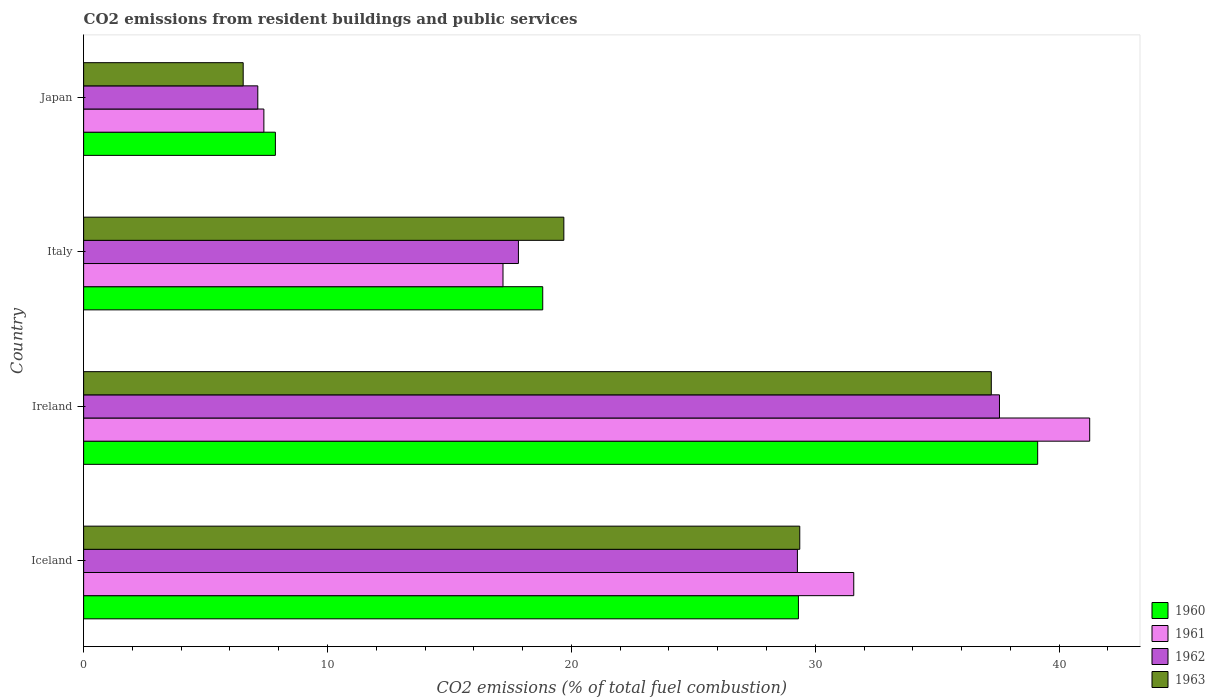Are the number of bars per tick equal to the number of legend labels?
Give a very brief answer. Yes. How many bars are there on the 1st tick from the top?
Offer a very short reply. 4. How many bars are there on the 3rd tick from the bottom?
Your response must be concise. 4. What is the total CO2 emitted in 1962 in Ireland?
Offer a very short reply. 37.55. Across all countries, what is the maximum total CO2 emitted in 1961?
Keep it short and to the point. 41.25. Across all countries, what is the minimum total CO2 emitted in 1963?
Give a very brief answer. 6.54. In which country was the total CO2 emitted in 1961 maximum?
Your answer should be very brief. Ireland. What is the total total CO2 emitted in 1962 in the graph?
Make the answer very short. 91.79. What is the difference between the total CO2 emitted in 1962 in Iceland and that in Ireland?
Your answer should be very brief. -8.29. What is the difference between the total CO2 emitted in 1962 in Japan and the total CO2 emitted in 1963 in Iceland?
Your answer should be compact. -22.22. What is the average total CO2 emitted in 1962 per country?
Your answer should be very brief. 22.95. What is the difference between the total CO2 emitted in 1961 and total CO2 emitted in 1962 in Iceland?
Provide a succinct answer. 2.31. What is the ratio of the total CO2 emitted in 1961 in Italy to that in Japan?
Provide a short and direct response. 2.33. What is the difference between the highest and the second highest total CO2 emitted in 1962?
Provide a succinct answer. 8.29. What is the difference between the highest and the lowest total CO2 emitted in 1962?
Ensure brevity in your answer.  30.41. In how many countries, is the total CO2 emitted in 1960 greater than the average total CO2 emitted in 1960 taken over all countries?
Give a very brief answer. 2. Is it the case that in every country, the sum of the total CO2 emitted in 1963 and total CO2 emitted in 1960 is greater than the sum of total CO2 emitted in 1962 and total CO2 emitted in 1961?
Your response must be concise. No. What does the 3rd bar from the bottom in Japan represents?
Make the answer very short. 1962. Is it the case that in every country, the sum of the total CO2 emitted in 1962 and total CO2 emitted in 1960 is greater than the total CO2 emitted in 1961?
Keep it short and to the point. Yes. How many bars are there?
Keep it short and to the point. 16. What is the difference between two consecutive major ticks on the X-axis?
Ensure brevity in your answer.  10. Are the values on the major ticks of X-axis written in scientific E-notation?
Your answer should be compact. No. Does the graph contain any zero values?
Keep it short and to the point. No. Does the graph contain grids?
Your answer should be compact. No. Where does the legend appear in the graph?
Provide a succinct answer. Bottom right. How many legend labels are there?
Your response must be concise. 4. How are the legend labels stacked?
Make the answer very short. Vertical. What is the title of the graph?
Ensure brevity in your answer.  CO2 emissions from resident buildings and public services. Does "1996" appear as one of the legend labels in the graph?
Provide a short and direct response. No. What is the label or title of the X-axis?
Provide a short and direct response. CO2 emissions (% of total fuel combustion). What is the label or title of the Y-axis?
Your answer should be very brief. Country. What is the CO2 emissions (% of total fuel combustion) of 1960 in Iceland?
Give a very brief answer. 29.31. What is the CO2 emissions (% of total fuel combustion) of 1961 in Iceland?
Keep it short and to the point. 31.58. What is the CO2 emissions (% of total fuel combustion) in 1962 in Iceland?
Make the answer very short. 29.27. What is the CO2 emissions (% of total fuel combustion) in 1963 in Iceland?
Keep it short and to the point. 29.37. What is the CO2 emissions (% of total fuel combustion) in 1960 in Ireland?
Offer a very short reply. 39.12. What is the CO2 emissions (% of total fuel combustion) of 1961 in Ireland?
Offer a terse response. 41.25. What is the CO2 emissions (% of total fuel combustion) of 1962 in Ireland?
Offer a very short reply. 37.55. What is the CO2 emissions (% of total fuel combustion) of 1963 in Ireland?
Offer a very short reply. 37.22. What is the CO2 emissions (% of total fuel combustion) of 1960 in Italy?
Make the answer very short. 18.83. What is the CO2 emissions (% of total fuel combustion) in 1961 in Italy?
Provide a succinct answer. 17.2. What is the CO2 emissions (% of total fuel combustion) in 1962 in Italy?
Your response must be concise. 17.83. What is the CO2 emissions (% of total fuel combustion) of 1963 in Italy?
Offer a terse response. 19.69. What is the CO2 emissions (% of total fuel combustion) of 1960 in Japan?
Keep it short and to the point. 7.86. What is the CO2 emissions (% of total fuel combustion) in 1961 in Japan?
Provide a succinct answer. 7.39. What is the CO2 emissions (% of total fuel combustion) in 1962 in Japan?
Offer a very short reply. 7.14. What is the CO2 emissions (% of total fuel combustion) of 1963 in Japan?
Offer a very short reply. 6.54. Across all countries, what is the maximum CO2 emissions (% of total fuel combustion) of 1960?
Your answer should be very brief. 39.12. Across all countries, what is the maximum CO2 emissions (% of total fuel combustion) of 1961?
Your answer should be compact. 41.25. Across all countries, what is the maximum CO2 emissions (% of total fuel combustion) in 1962?
Offer a terse response. 37.55. Across all countries, what is the maximum CO2 emissions (% of total fuel combustion) in 1963?
Offer a very short reply. 37.22. Across all countries, what is the minimum CO2 emissions (% of total fuel combustion) of 1960?
Keep it short and to the point. 7.86. Across all countries, what is the minimum CO2 emissions (% of total fuel combustion) of 1961?
Ensure brevity in your answer.  7.39. Across all countries, what is the minimum CO2 emissions (% of total fuel combustion) in 1962?
Your answer should be very brief. 7.14. Across all countries, what is the minimum CO2 emissions (% of total fuel combustion) of 1963?
Make the answer very short. 6.54. What is the total CO2 emissions (% of total fuel combustion) of 1960 in the graph?
Make the answer very short. 95.12. What is the total CO2 emissions (% of total fuel combustion) of 1961 in the graph?
Your answer should be compact. 97.42. What is the total CO2 emissions (% of total fuel combustion) in 1962 in the graph?
Ensure brevity in your answer.  91.79. What is the total CO2 emissions (% of total fuel combustion) in 1963 in the graph?
Provide a short and direct response. 92.82. What is the difference between the CO2 emissions (% of total fuel combustion) in 1960 in Iceland and that in Ireland?
Your response must be concise. -9.81. What is the difference between the CO2 emissions (% of total fuel combustion) in 1961 in Iceland and that in Ireland?
Your answer should be compact. -9.67. What is the difference between the CO2 emissions (% of total fuel combustion) in 1962 in Iceland and that in Ireland?
Give a very brief answer. -8.29. What is the difference between the CO2 emissions (% of total fuel combustion) in 1963 in Iceland and that in Ireland?
Ensure brevity in your answer.  -7.85. What is the difference between the CO2 emissions (% of total fuel combustion) of 1960 in Iceland and that in Italy?
Make the answer very short. 10.48. What is the difference between the CO2 emissions (% of total fuel combustion) in 1961 in Iceland and that in Italy?
Make the answer very short. 14.38. What is the difference between the CO2 emissions (% of total fuel combustion) in 1962 in Iceland and that in Italy?
Offer a very short reply. 11.44. What is the difference between the CO2 emissions (% of total fuel combustion) in 1963 in Iceland and that in Italy?
Make the answer very short. 9.67. What is the difference between the CO2 emissions (% of total fuel combustion) of 1960 in Iceland and that in Japan?
Ensure brevity in your answer.  21.45. What is the difference between the CO2 emissions (% of total fuel combustion) of 1961 in Iceland and that in Japan?
Offer a very short reply. 24.19. What is the difference between the CO2 emissions (% of total fuel combustion) in 1962 in Iceland and that in Japan?
Give a very brief answer. 22.13. What is the difference between the CO2 emissions (% of total fuel combustion) of 1963 in Iceland and that in Japan?
Keep it short and to the point. 22.82. What is the difference between the CO2 emissions (% of total fuel combustion) in 1960 in Ireland and that in Italy?
Offer a terse response. 20.29. What is the difference between the CO2 emissions (% of total fuel combustion) in 1961 in Ireland and that in Italy?
Your answer should be very brief. 24.06. What is the difference between the CO2 emissions (% of total fuel combustion) of 1962 in Ireland and that in Italy?
Ensure brevity in your answer.  19.73. What is the difference between the CO2 emissions (% of total fuel combustion) in 1963 in Ireland and that in Italy?
Offer a terse response. 17.53. What is the difference between the CO2 emissions (% of total fuel combustion) in 1960 in Ireland and that in Japan?
Your answer should be compact. 31.26. What is the difference between the CO2 emissions (% of total fuel combustion) in 1961 in Ireland and that in Japan?
Provide a short and direct response. 33.86. What is the difference between the CO2 emissions (% of total fuel combustion) of 1962 in Ireland and that in Japan?
Provide a short and direct response. 30.41. What is the difference between the CO2 emissions (% of total fuel combustion) of 1963 in Ireland and that in Japan?
Ensure brevity in your answer.  30.68. What is the difference between the CO2 emissions (% of total fuel combustion) of 1960 in Italy and that in Japan?
Give a very brief answer. 10.96. What is the difference between the CO2 emissions (% of total fuel combustion) of 1961 in Italy and that in Japan?
Offer a very short reply. 9.81. What is the difference between the CO2 emissions (% of total fuel combustion) in 1962 in Italy and that in Japan?
Ensure brevity in your answer.  10.69. What is the difference between the CO2 emissions (% of total fuel combustion) in 1963 in Italy and that in Japan?
Offer a very short reply. 13.15. What is the difference between the CO2 emissions (% of total fuel combustion) in 1960 in Iceland and the CO2 emissions (% of total fuel combustion) in 1961 in Ireland?
Your answer should be compact. -11.94. What is the difference between the CO2 emissions (% of total fuel combustion) in 1960 in Iceland and the CO2 emissions (% of total fuel combustion) in 1962 in Ireland?
Your answer should be compact. -8.24. What is the difference between the CO2 emissions (% of total fuel combustion) of 1960 in Iceland and the CO2 emissions (% of total fuel combustion) of 1963 in Ireland?
Your answer should be compact. -7.91. What is the difference between the CO2 emissions (% of total fuel combustion) in 1961 in Iceland and the CO2 emissions (% of total fuel combustion) in 1962 in Ireland?
Your answer should be compact. -5.98. What is the difference between the CO2 emissions (% of total fuel combustion) of 1961 in Iceland and the CO2 emissions (% of total fuel combustion) of 1963 in Ireland?
Offer a terse response. -5.64. What is the difference between the CO2 emissions (% of total fuel combustion) of 1962 in Iceland and the CO2 emissions (% of total fuel combustion) of 1963 in Ireland?
Keep it short and to the point. -7.95. What is the difference between the CO2 emissions (% of total fuel combustion) in 1960 in Iceland and the CO2 emissions (% of total fuel combustion) in 1961 in Italy?
Your response must be concise. 12.11. What is the difference between the CO2 emissions (% of total fuel combustion) in 1960 in Iceland and the CO2 emissions (% of total fuel combustion) in 1962 in Italy?
Keep it short and to the point. 11.48. What is the difference between the CO2 emissions (% of total fuel combustion) in 1960 in Iceland and the CO2 emissions (% of total fuel combustion) in 1963 in Italy?
Provide a short and direct response. 9.62. What is the difference between the CO2 emissions (% of total fuel combustion) of 1961 in Iceland and the CO2 emissions (% of total fuel combustion) of 1962 in Italy?
Keep it short and to the point. 13.75. What is the difference between the CO2 emissions (% of total fuel combustion) of 1961 in Iceland and the CO2 emissions (% of total fuel combustion) of 1963 in Italy?
Provide a succinct answer. 11.89. What is the difference between the CO2 emissions (% of total fuel combustion) of 1962 in Iceland and the CO2 emissions (% of total fuel combustion) of 1963 in Italy?
Offer a very short reply. 9.58. What is the difference between the CO2 emissions (% of total fuel combustion) of 1960 in Iceland and the CO2 emissions (% of total fuel combustion) of 1961 in Japan?
Keep it short and to the point. 21.92. What is the difference between the CO2 emissions (% of total fuel combustion) in 1960 in Iceland and the CO2 emissions (% of total fuel combustion) in 1962 in Japan?
Keep it short and to the point. 22.17. What is the difference between the CO2 emissions (% of total fuel combustion) of 1960 in Iceland and the CO2 emissions (% of total fuel combustion) of 1963 in Japan?
Keep it short and to the point. 22.77. What is the difference between the CO2 emissions (% of total fuel combustion) in 1961 in Iceland and the CO2 emissions (% of total fuel combustion) in 1962 in Japan?
Offer a very short reply. 24.44. What is the difference between the CO2 emissions (% of total fuel combustion) of 1961 in Iceland and the CO2 emissions (% of total fuel combustion) of 1963 in Japan?
Keep it short and to the point. 25.04. What is the difference between the CO2 emissions (% of total fuel combustion) in 1962 in Iceland and the CO2 emissions (% of total fuel combustion) in 1963 in Japan?
Make the answer very short. 22.73. What is the difference between the CO2 emissions (% of total fuel combustion) in 1960 in Ireland and the CO2 emissions (% of total fuel combustion) in 1961 in Italy?
Provide a short and direct response. 21.92. What is the difference between the CO2 emissions (% of total fuel combustion) in 1960 in Ireland and the CO2 emissions (% of total fuel combustion) in 1962 in Italy?
Provide a short and direct response. 21.29. What is the difference between the CO2 emissions (% of total fuel combustion) of 1960 in Ireland and the CO2 emissions (% of total fuel combustion) of 1963 in Italy?
Keep it short and to the point. 19.43. What is the difference between the CO2 emissions (% of total fuel combustion) of 1961 in Ireland and the CO2 emissions (% of total fuel combustion) of 1962 in Italy?
Provide a short and direct response. 23.42. What is the difference between the CO2 emissions (% of total fuel combustion) of 1961 in Ireland and the CO2 emissions (% of total fuel combustion) of 1963 in Italy?
Offer a terse response. 21.56. What is the difference between the CO2 emissions (% of total fuel combustion) in 1962 in Ireland and the CO2 emissions (% of total fuel combustion) in 1963 in Italy?
Offer a terse response. 17.86. What is the difference between the CO2 emissions (% of total fuel combustion) in 1960 in Ireland and the CO2 emissions (% of total fuel combustion) in 1961 in Japan?
Provide a succinct answer. 31.73. What is the difference between the CO2 emissions (% of total fuel combustion) in 1960 in Ireland and the CO2 emissions (% of total fuel combustion) in 1962 in Japan?
Give a very brief answer. 31.98. What is the difference between the CO2 emissions (% of total fuel combustion) of 1960 in Ireland and the CO2 emissions (% of total fuel combustion) of 1963 in Japan?
Your response must be concise. 32.58. What is the difference between the CO2 emissions (% of total fuel combustion) of 1961 in Ireland and the CO2 emissions (% of total fuel combustion) of 1962 in Japan?
Offer a very short reply. 34.11. What is the difference between the CO2 emissions (% of total fuel combustion) in 1961 in Ireland and the CO2 emissions (% of total fuel combustion) in 1963 in Japan?
Offer a terse response. 34.71. What is the difference between the CO2 emissions (% of total fuel combustion) in 1962 in Ireland and the CO2 emissions (% of total fuel combustion) in 1963 in Japan?
Ensure brevity in your answer.  31.01. What is the difference between the CO2 emissions (% of total fuel combustion) of 1960 in Italy and the CO2 emissions (% of total fuel combustion) of 1961 in Japan?
Ensure brevity in your answer.  11.43. What is the difference between the CO2 emissions (% of total fuel combustion) in 1960 in Italy and the CO2 emissions (% of total fuel combustion) in 1962 in Japan?
Your answer should be very brief. 11.68. What is the difference between the CO2 emissions (% of total fuel combustion) of 1960 in Italy and the CO2 emissions (% of total fuel combustion) of 1963 in Japan?
Offer a terse response. 12.28. What is the difference between the CO2 emissions (% of total fuel combustion) in 1961 in Italy and the CO2 emissions (% of total fuel combustion) in 1962 in Japan?
Your response must be concise. 10.05. What is the difference between the CO2 emissions (% of total fuel combustion) in 1961 in Italy and the CO2 emissions (% of total fuel combustion) in 1963 in Japan?
Keep it short and to the point. 10.65. What is the difference between the CO2 emissions (% of total fuel combustion) in 1962 in Italy and the CO2 emissions (% of total fuel combustion) in 1963 in Japan?
Provide a succinct answer. 11.29. What is the average CO2 emissions (% of total fuel combustion) in 1960 per country?
Ensure brevity in your answer.  23.78. What is the average CO2 emissions (% of total fuel combustion) of 1961 per country?
Your response must be concise. 24.36. What is the average CO2 emissions (% of total fuel combustion) of 1962 per country?
Keep it short and to the point. 22.95. What is the average CO2 emissions (% of total fuel combustion) in 1963 per country?
Offer a terse response. 23.2. What is the difference between the CO2 emissions (% of total fuel combustion) of 1960 and CO2 emissions (% of total fuel combustion) of 1961 in Iceland?
Provide a succinct answer. -2.27. What is the difference between the CO2 emissions (% of total fuel combustion) of 1960 and CO2 emissions (% of total fuel combustion) of 1962 in Iceland?
Keep it short and to the point. 0.04. What is the difference between the CO2 emissions (% of total fuel combustion) in 1960 and CO2 emissions (% of total fuel combustion) in 1963 in Iceland?
Make the answer very short. -0.05. What is the difference between the CO2 emissions (% of total fuel combustion) of 1961 and CO2 emissions (% of total fuel combustion) of 1962 in Iceland?
Provide a succinct answer. 2.31. What is the difference between the CO2 emissions (% of total fuel combustion) of 1961 and CO2 emissions (% of total fuel combustion) of 1963 in Iceland?
Give a very brief answer. 2.21. What is the difference between the CO2 emissions (% of total fuel combustion) in 1962 and CO2 emissions (% of total fuel combustion) in 1963 in Iceland?
Provide a succinct answer. -0.1. What is the difference between the CO2 emissions (% of total fuel combustion) in 1960 and CO2 emissions (% of total fuel combustion) in 1961 in Ireland?
Keep it short and to the point. -2.13. What is the difference between the CO2 emissions (% of total fuel combustion) in 1960 and CO2 emissions (% of total fuel combustion) in 1962 in Ireland?
Your answer should be compact. 1.57. What is the difference between the CO2 emissions (% of total fuel combustion) of 1960 and CO2 emissions (% of total fuel combustion) of 1963 in Ireland?
Ensure brevity in your answer.  1.9. What is the difference between the CO2 emissions (% of total fuel combustion) in 1961 and CO2 emissions (% of total fuel combustion) in 1962 in Ireland?
Offer a very short reply. 3.7. What is the difference between the CO2 emissions (% of total fuel combustion) in 1961 and CO2 emissions (% of total fuel combustion) in 1963 in Ireland?
Offer a very short reply. 4.03. What is the difference between the CO2 emissions (% of total fuel combustion) in 1962 and CO2 emissions (% of total fuel combustion) in 1963 in Ireland?
Offer a terse response. 0.34. What is the difference between the CO2 emissions (% of total fuel combustion) in 1960 and CO2 emissions (% of total fuel combustion) in 1961 in Italy?
Your answer should be very brief. 1.63. What is the difference between the CO2 emissions (% of total fuel combustion) in 1960 and CO2 emissions (% of total fuel combustion) in 1963 in Italy?
Give a very brief answer. -0.87. What is the difference between the CO2 emissions (% of total fuel combustion) of 1961 and CO2 emissions (% of total fuel combustion) of 1962 in Italy?
Provide a succinct answer. -0.63. What is the difference between the CO2 emissions (% of total fuel combustion) of 1961 and CO2 emissions (% of total fuel combustion) of 1963 in Italy?
Ensure brevity in your answer.  -2.49. What is the difference between the CO2 emissions (% of total fuel combustion) in 1962 and CO2 emissions (% of total fuel combustion) in 1963 in Italy?
Your answer should be compact. -1.86. What is the difference between the CO2 emissions (% of total fuel combustion) in 1960 and CO2 emissions (% of total fuel combustion) in 1961 in Japan?
Make the answer very short. 0.47. What is the difference between the CO2 emissions (% of total fuel combustion) of 1960 and CO2 emissions (% of total fuel combustion) of 1962 in Japan?
Make the answer very short. 0.72. What is the difference between the CO2 emissions (% of total fuel combustion) of 1960 and CO2 emissions (% of total fuel combustion) of 1963 in Japan?
Provide a succinct answer. 1.32. What is the difference between the CO2 emissions (% of total fuel combustion) of 1961 and CO2 emissions (% of total fuel combustion) of 1962 in Japan?
Your answer should be compact. 0.25. What is the difference between the CO2 emissions (% of total fuel combustion) in 1961 and CO2 emissions (% of total fuel combustion) in 1963 in Japan?
Offer a very short reply. 0.85. What is the difference between the CO2 emissions (% of total fuel combustion) of 1962 and CO2 emissions (% of total fuel combustion) of 1963 in Japan?
Provide a succinct answer. 0.6. What is the ratio of the CO2 emissions (% of total fuel combustion) of 1960 in Iceland to that in Ireland?
Make the answer very short. 0.75. What is the ratio of the CO2 emissions (% of total fuel combustion) in 1961 in Iceland to that in Ireland?
Offer a terse response. 0.77. What is the ratio of the CO2 emissions (% of total fuel combustion) of 1962 in Iceland to that in Ireland?
Your answer should be compact. 0.78. What is the ratio of the CO2 emissions (% of total fuel combustion) in 1963 in Iceland to that in Ireland?
Your answer should be compact. 0.79. What is the ratio of the CO2 emissions (% of total fuel combustion) of 1960 in Iceland to that in Italy?
Your response must be concise. 1.56. What is the ratio of the CO2 emissions (% of total fuel combustion) of 1961 in Iceland to that in Italy?
Provide a succinct answer. 1.84. What is the ratio of the CO2 emissions (% of total fuel combustion) in 1962 in Iceland to that in Italy?
Offer a terse response. 1.64. What is the ratio of the CO2 emissions (% of total fuel combustion) of 1963 in Iceland to that in Italy?
Make the answer very short. 1.49. What is the ratio of the CO2 emissions (% of total fuel combustion) in 1960 in Iceland to that in Japan?
Offer a terse response. 3.73. What is the ratio of the CO2 emissions (% of total fuel combustion) in 1961 in Iceland to that in Japan?
Your answer should be very brief. 4.27. What is the ratio of the CO2 emissions (% of total fuel combustion) in 1962 in Iceland to that in Japan?
Provide a short and direct response. 4.1. What is the ratio of the CO2 emissions (% of total fuel combustion) of 1963 in Iceland to that in Japan?
Ensure brevity in your answer.  4.49. What is the ratio of the CO2 emissions (% of total fuel combustion) in 1960 in Ireland to that in Italy?
Offer a terse response. 2.08. What is the ratio of the CO2 emissions (% of total fuel combustion) in 1961 in Ireland to that in Italy?
Your answer should be very brief. 2.4. What is the ratio of the CO2 emissions (% of total fuel combustion) in 1962 in Ireland to that in Italy?
Your answer should be compact. 2.11. What is the ratio of the CO2 emissions (% of total fuel combustion) in 1963 in Ireland to that in Italy?
Offer a terse response. 1.89. What is the ratio of the CO2 emissions (% of total fuel combustion) of 1960 in Ireland to that in Japan?
Make the answer very short. 4.98. What is the ratio of the CO2 emissions (% of total fuel combustion) in 1961 in Ireland to that in Japan?
Offer a very short reply. 5.58. What is the ratio of the CO2 emissions (% of total fuel combustion) in 1962 in Ireland to that in Japan?
Give a very brief answer. 5.26. What is the ratio of the CO2 emissions (% of total fuel combustion) of 1963 in Ireland to that in Japan?
Keep it short and to the point. 5.69. What is the ratio of the CO2 emissions (% of total fuel combustion) in 1960 in Italy to that in Japan?
Your response must be concise. 2.39. What is the ratio of the CO2 emissions (% of total fuel combustion) of 1961 in Italy to that in Japan?
Give a very brief answer. 2.33. What is the ratio of the CO2 emissions (% of total fuel combustion) of 1962 in Italy to that in Japan?
Offer a terse response. 2.5. What is the ratio of the CO2 emissions (% of total fuel combustion) in 1963 in Italy to that in Japan?
Make the answer very short. 3.01. What is the difference between the highest and the second highest CO2 emissions (% of total fuel combustion) in 1960?
Your answer should be very brief. 9.81. What is the difference between the highest and the second highest CO2 emissions (% of total fuel combustion) of 1961?
Ensure brevity in your answer.  9.67. What is the difference between the highest and the second highest CO2 emissions (% of total fuel combustion) in 1962?
Provide a succinct answer. 8.29. What is the difference between the highest and the second highest CO2 emissions (% of total fuel combustion) of 1963?
Provide a short and direct response. 7.85. What is the difference between the highest and the lowest CO2 emissions (% of total fuel combustion) of 1960?
Ensure brevity in your answer.  31.26. What is the difference between the highest and the lowest CO2 emissions (% of total fuel combustion) in 1961?
Your answer should be very brief. 33.86. What is the difference between the highest and the lowest CO2 emissions (% of total fuel combustion) in 1962?
Give a very brief answer. 30.41. What is the difference between the highest and the lowest CO2 emissions (% of total fuel combustion) in 1963?
Ensure brevity in your answer.  30.68. 